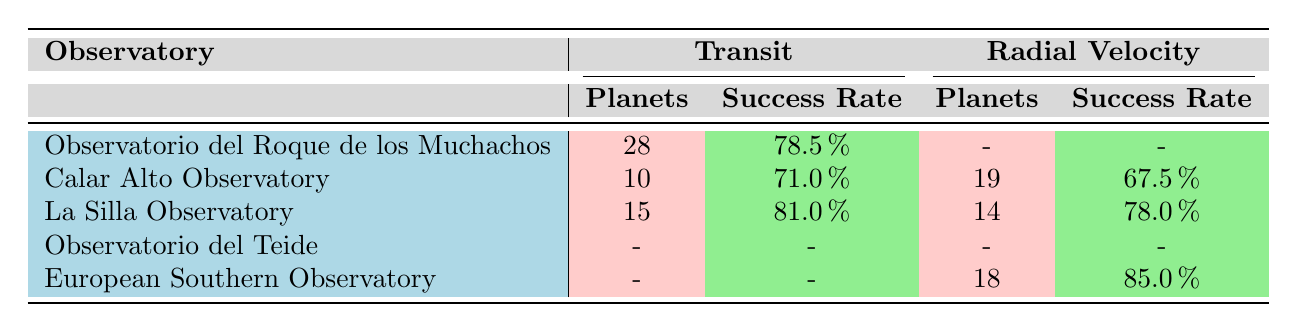What is the total number of exoplanets detected by the La Silla Observatory using the Transit method? The table indicates that the La Silla Observatory detected 15 planets using the Transit method.
Answer: 15 What is the success rate of the European Southern Observatory for the Radial Velocity method? The table shows that the European Southern Observatory achieved a success rate of 85 percent for the Radial Velocity method.
Answer: 85 percent Which observatory had the highest success rate for the Transit method? By examining the data, La Silla Observatory has the highest success rate of 81 percent for the Transit method.
Answer: La Silla Observatory How many total planets were detected by the Calar Alto Observatory across both methods? The total planets detected by Calar Alto Observatory is calculated by summing the planets detected through Transit (10) and Radial Velocity (19), resulting in a total of 29 planets.
Answer: 29 Is it true that the Observatorio del Teide did not have any detections recorded for the Transit or Radial Velocity methods? The table indicates there are no recorded detections for any method for the Observatorio del Teide, making this statement true.
Answer: Yes What is the average success rate for the Radial Velocity method across all observatories listed? The success rates for Radial Velocity are 67.5 percent from Calar Alto Observatory, 78.0 percent from La Silla Observatory, and 85.0 percent from the European Southern Observatory. The average is calculated as (67.5 + 78.0 + 85.0) / 3 = 76.5 percent.
Answer: 76.5 percent Which observatory showed the lowest success rate in any detection method? The Observatorio del Teide had the lowest success rate of 25 percent in the Astrometry method, as indicated in the data.
Answer: Observatorio del Teide How many more exoplanets were detected by the European Southern Observatory compared to the Calar Alto Observatory? The European Southern Observatory detected 18 exoplanets (Radial Velocity), while Calar Alto Observatory detected a total of 29 planets (10 Transit and 19 Radial Velocity). The difference is 29 - 18 = 11 planets, indicating Calar Alto detected 11 more planets.
Answer: 11 planets What is the overall number of planets detected by the Observatorio del Roque de los Muchachos in the Transit method? The overall total for the Transit method at the Observatorio del Roque de los Muchachos is calculated by summing the 12 planets detected in 2018, 16 in 2020, leading to a total of 28 planets detected through this method.
Answer: 28 